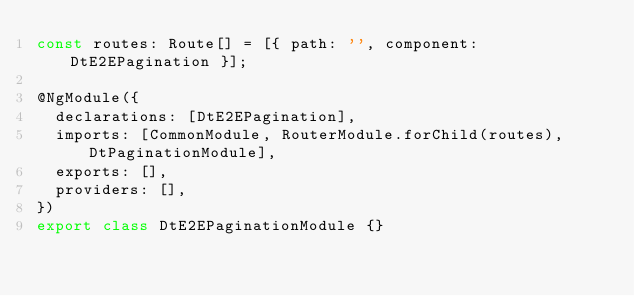<code> <loc_0><loc_0><loc_500><loc_500><_TypeScript_>const routes: Route[] = [{ path: '', component: DtE2EPagination }];

@NgModule({
  declarations: [DtE2EPagination],
  imports: [CommonModule, RouterModule.forChild(routes), DtPaginationModule],
  exports: [],
  providers: [],
})
export class DtE2EPaginationModule {}
</code> 